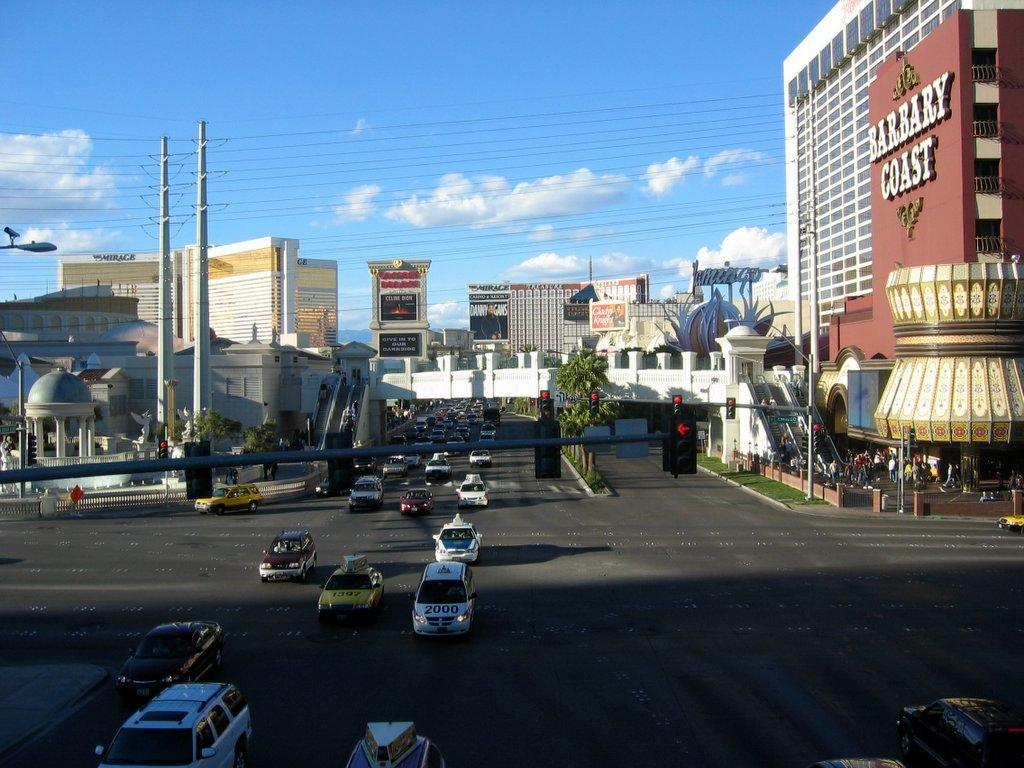What is the main feature of the image? There is a road in the image. What is happening on the road? There are cars moving on the road. What can be seen in the background of the image? There are buildings in the background of the image. What is visible in the sky? There are clouds visible in the sky. Can you see any icicles hanging from the buildings in the image? There are no icicles visible in the image; it appears to be a regular day with clouds in the sky. What type of noise can be heard coming from the cars in the image? The image is static, so no noise can be heard from the cars. 